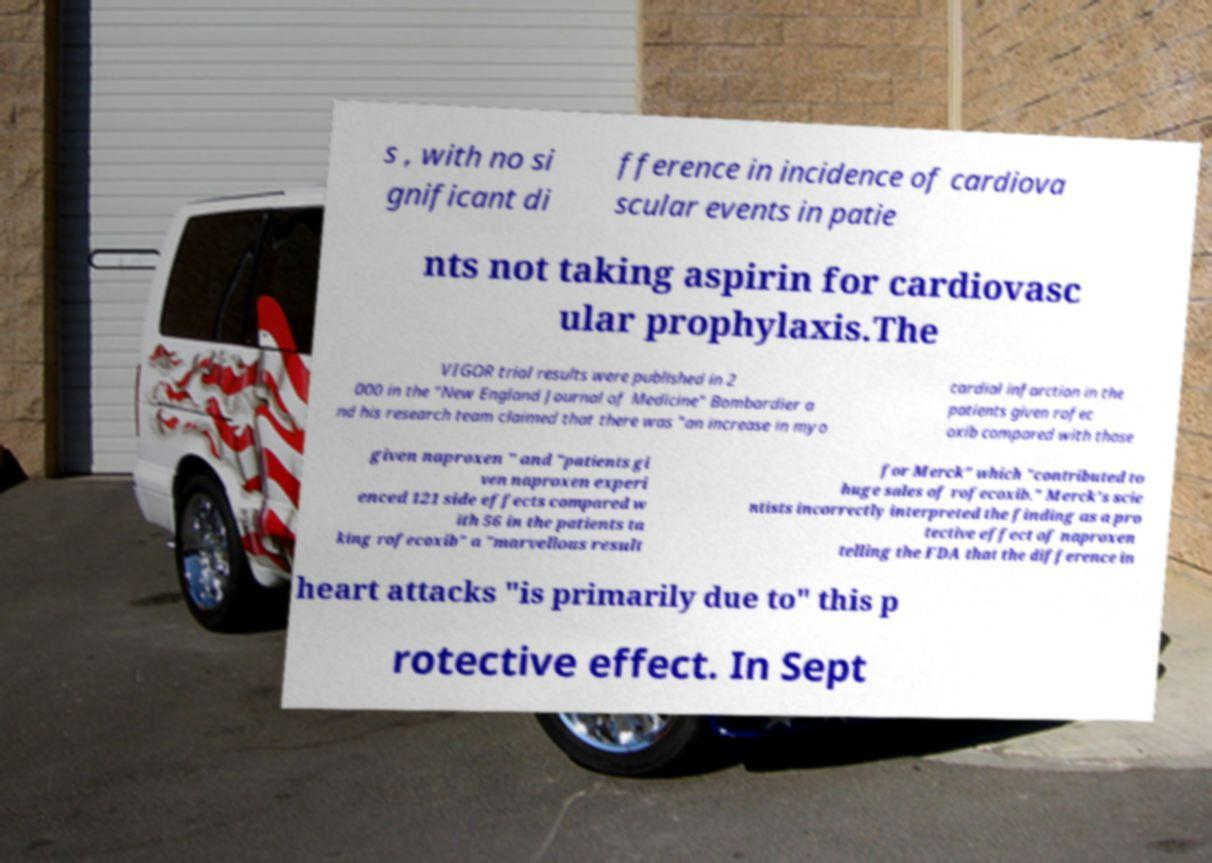Please read and relay the text visible in this image. What does it say? s , with no si gnificant di fference in incidence of cardiova scular events in patie nts not taking aspirin for cardiovasc ular prophylaxis.The VIGOR trial results were published in 2 000 in the "New England Journal of Medicine" Bombardier a nd his research team claimed that there was "an increase in myo cardial infarction in the patients given rofec oxib compared with those given naproxen " and "patients gi ven naproxen experi enced 121 side effects compared w ith 56 in the patients ta king rofecoxib" a "marvellous result for Merck" which "contributed to huge sales of rofecoxib." Merck's scie ntists incorrectly interpreted the finding as a pro tective effect of naproxen telling the FDA that the difference in heart attacks "is primarily due to" this p rotective effect. In Sept 